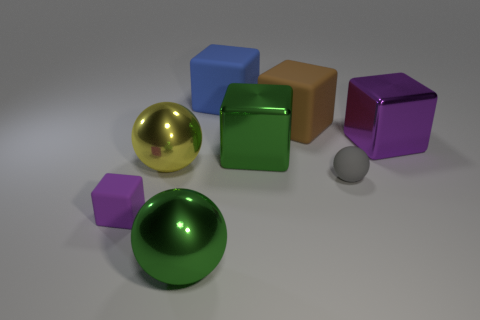Subtract all big green balls. How many balls are left? 2 Subtract all brown blocks. How many blocks are left? 4 Subtract all blocks. How many objects are left? 3 Subtract all big yellow metal balls. Subtract all small spheres. How many objects are left? 6 Add 8 metal cubes. How many metal cubes are left? 10 Add 5 metallic blocks. How many metallic blocks exist? 7 Add 2 big purple cylinders. How many objects exist? 10 Subtract 0 yellow cylinders. How many objects are left? 8 Subtract 5 cubes. How many cubes are left? 0 Subtract all yellow blocks. Subtract all purple balls. How many blocks are left? 5 